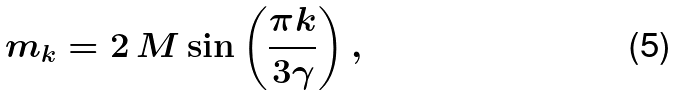Convert formula to latex. <formula><loc_0><loc_0><loc_500><loc_500>m _ { k } = 2 \, M \sin \left ( \frac { \pi k } { 3 \gamma } \right ) ,</formula> 